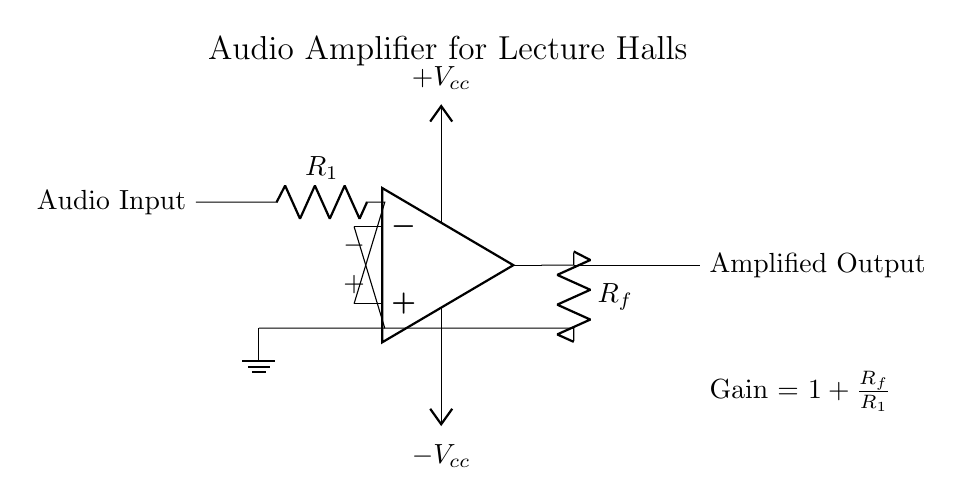What is the purpose of this circuit? The purpose of the circuit is to amplify audio signals, making them suitable for lecture halls. The operational amplifier is designed for audio applications by increasing the amplitude of the input signal.
Answer: audio amplification What component is used for feedback in the circuit? The feedback component is a resistor labeled R_f. It connects the output of the op-amp to the inverting input, helping to set the gain of the amplifier.
Answer: R_f What is the gain formula shown in the circuit? The gain formula is displayed on the right side of the op-amp circuit as Gain = 1 + R_f/R_1. This relation indicates how much the input signal will be amplified based on the resistor values.
Answer: 1 + R_f/R_1 What type of amplifier configuration is used in this circuit? This circuit configuration is known as a non-inverting amplifier. The signal is applied to the non-inverting input of the op-amp, providing a corresponding amplified output.
Answer: non-inverting What is the significance of the power supply voltages? The power supply voltages +V_cc and -V_cc provide the necessary power for the operational amplifier to function properly. These help ensure that the op-amp can output signals that swing both positively and negatively relative to ground.
Answer: necessary power Which terminal of the op-amp is connected to the audio input? The audio input is connected to the non-inverting terminal, indicated by the "+" sign in the circuit diagram. This terminal receives the input signal for amplification.
Answer: non-inverting terminal 